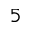Convert formula to latex. <formula><loc_0><loc_0><loc_500><loc_500>5</formula> 